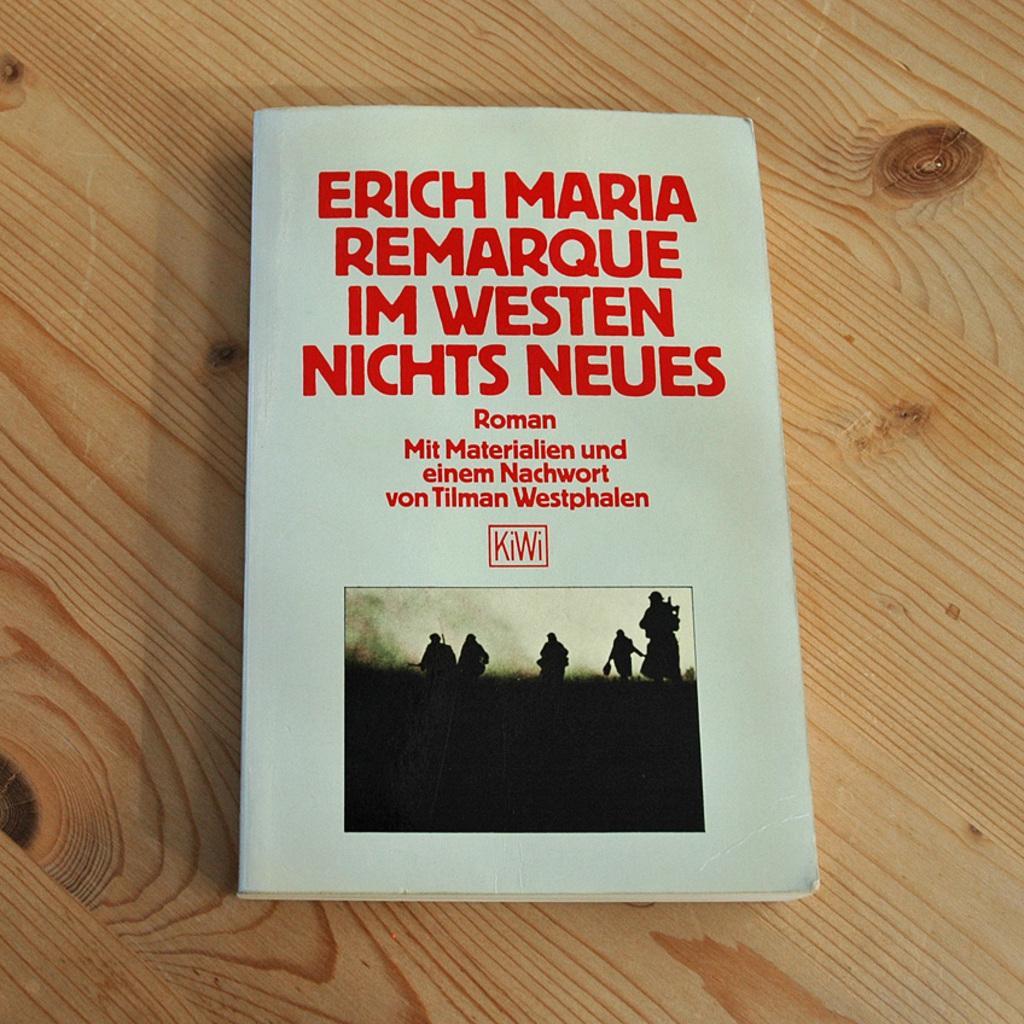Describe this image in one or two sentences. In this image we can see a book on a wooden surface. On the book we can see some text and image. In the image we can see the persons and the sky. 